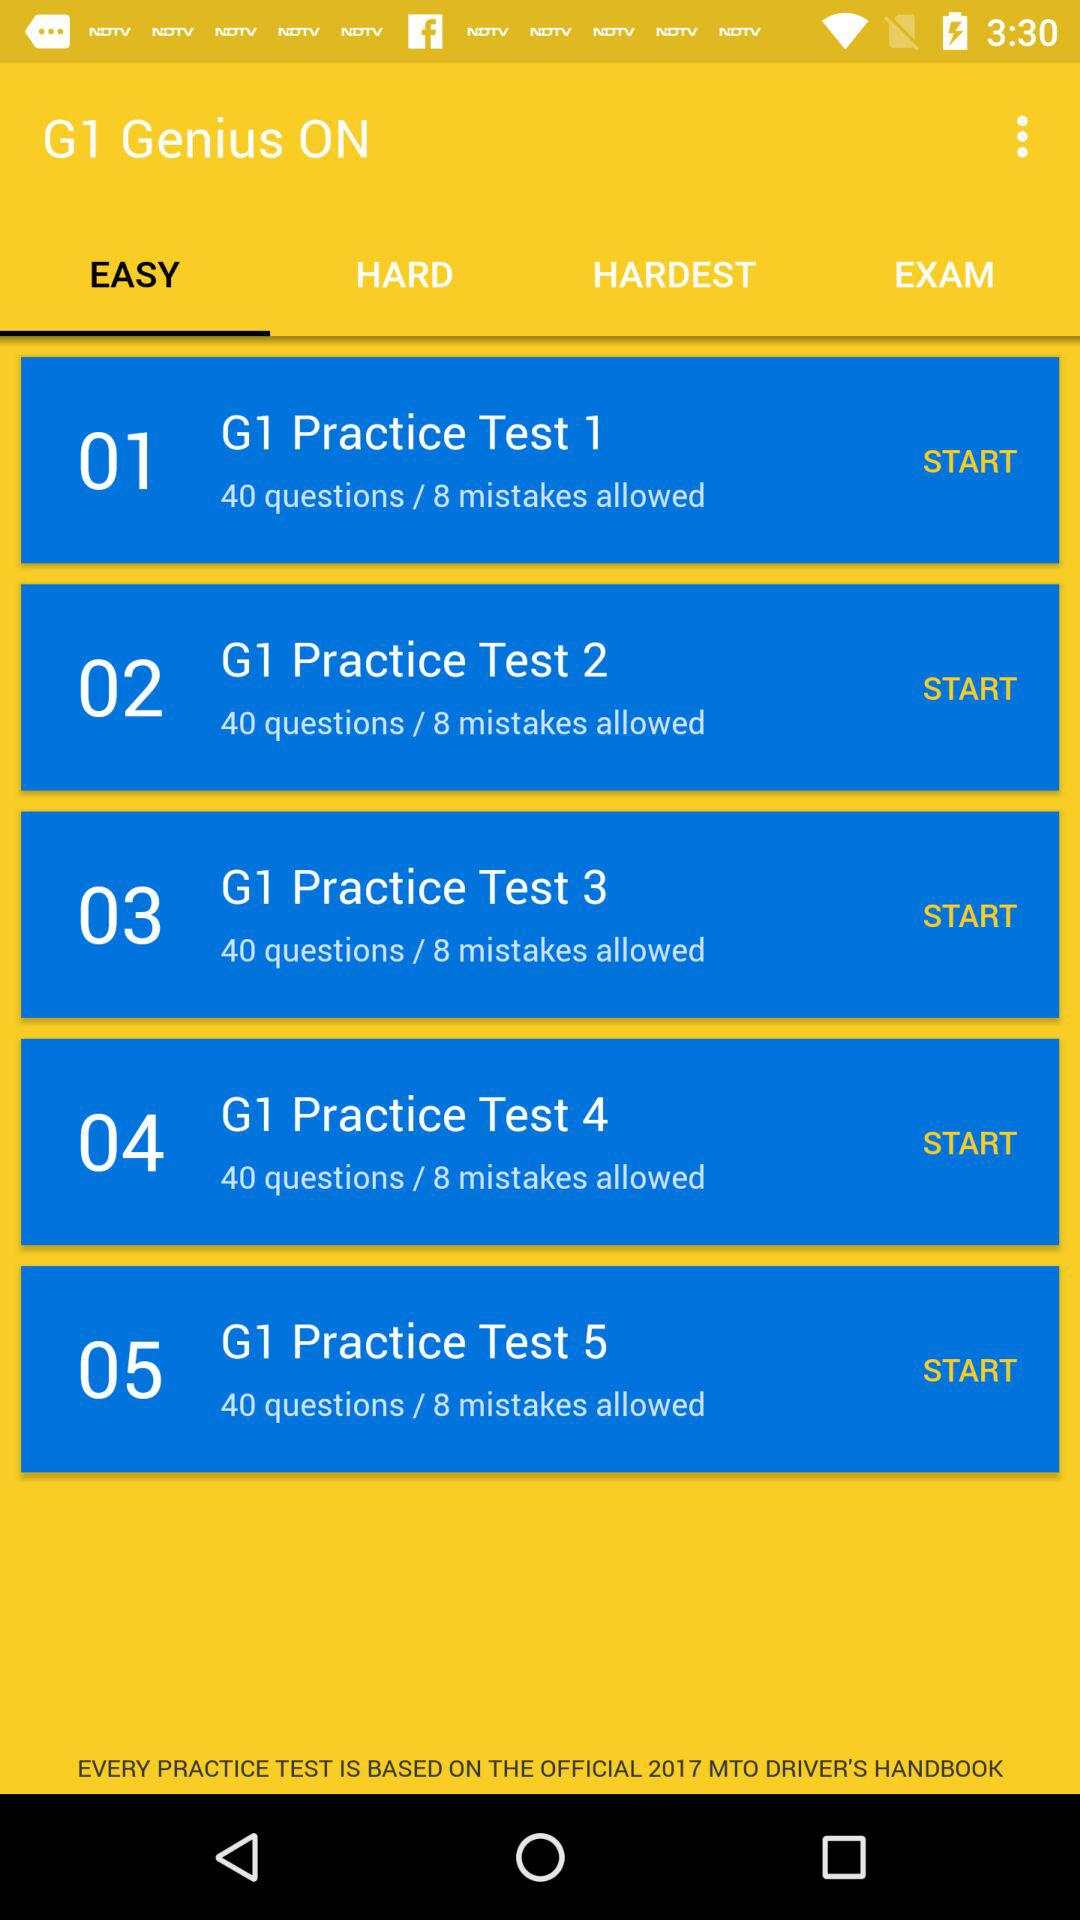How many questions are there in "G1 Practice Test 4"? There are 40 questions in "G1 Practice Test 4". 